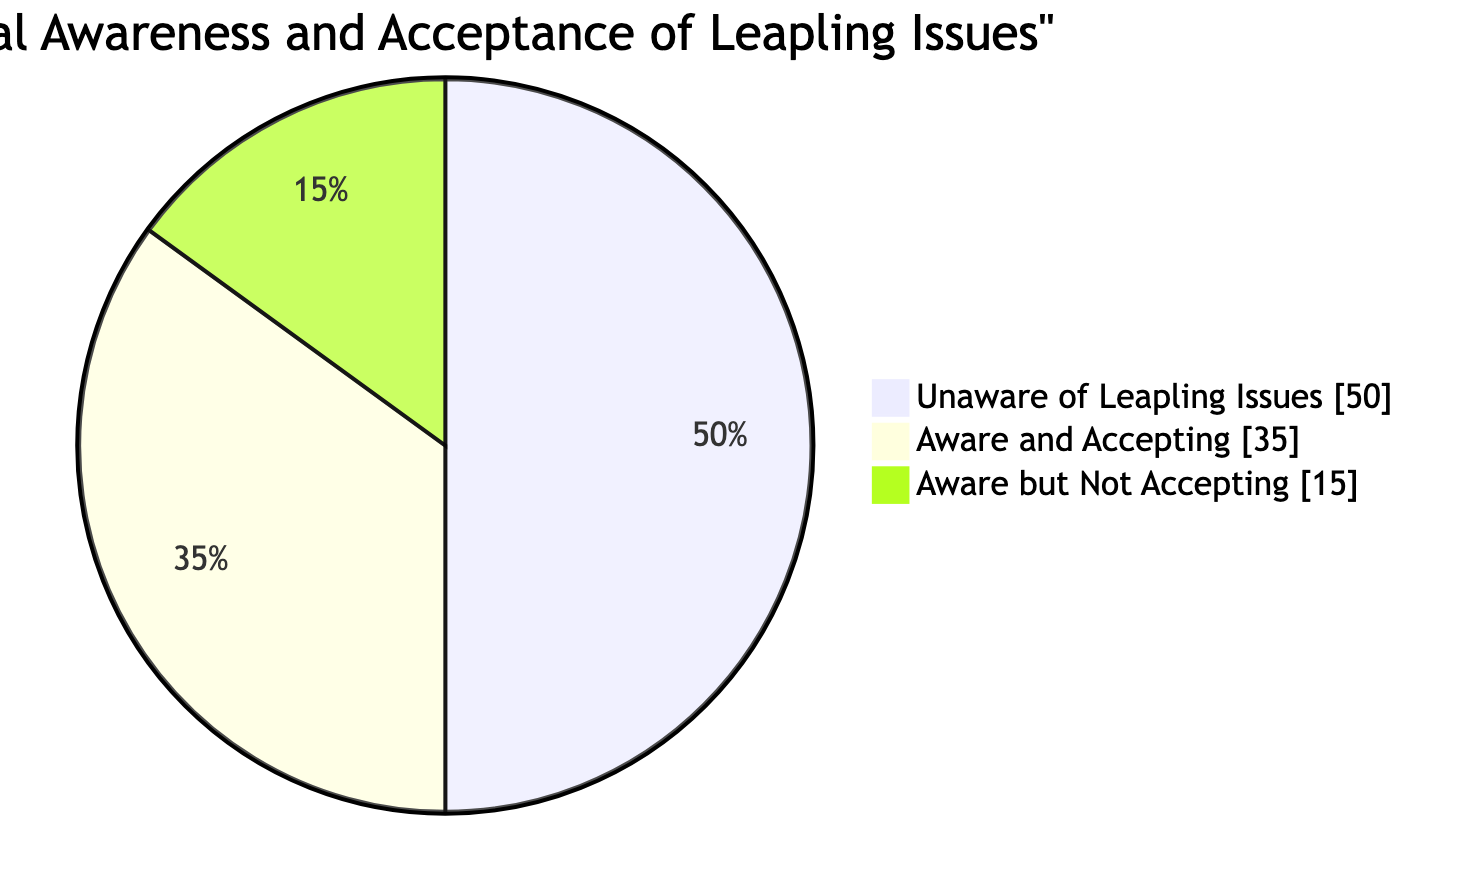What percentage of people are aware and accepting of leapling issues? The diagram indicates "Aware and Accepting" accounts for 35 percent of the total responses.
Answer: 35 percent What is the largest segment in the pie chart? "Unaware of Leapling Issues" is the largest segment, comprising 50 percent of the data shown in the pie chart.
Answer: Unaware of Leapling Issues How many total categories are represented in the diagram? There are three distinct categories represented in the diagram: "Aware and Accepting," "Aware but Not Accepting," and "Unaware of Leapling Issues."
Answer: 3 What percentage of people are aware but not accepting of leapling issues? The section "Aware but Not Accepting" corresponds to 15 percent, which represents those who are informed about the issues but not accepting of them.
Answer: 15 percent What is the combined percentage of those who are aware of leapling issues? To find the combined percentage, add the "Aware and Accepting" (35 percent) and "Aware but Not Accepting" (15 percent), which totals 50 percent of respondents who are aware.
Answer: 50 percent What can be inferred about societal acceptance of leapling issues based on the diagram? With only 35 percent of respondents being aware and accepting, while 50 percent are unaware, this suggests that there is a significant gap in societal acceptance and understanding of leapling issues.
Answer: Significant gap 